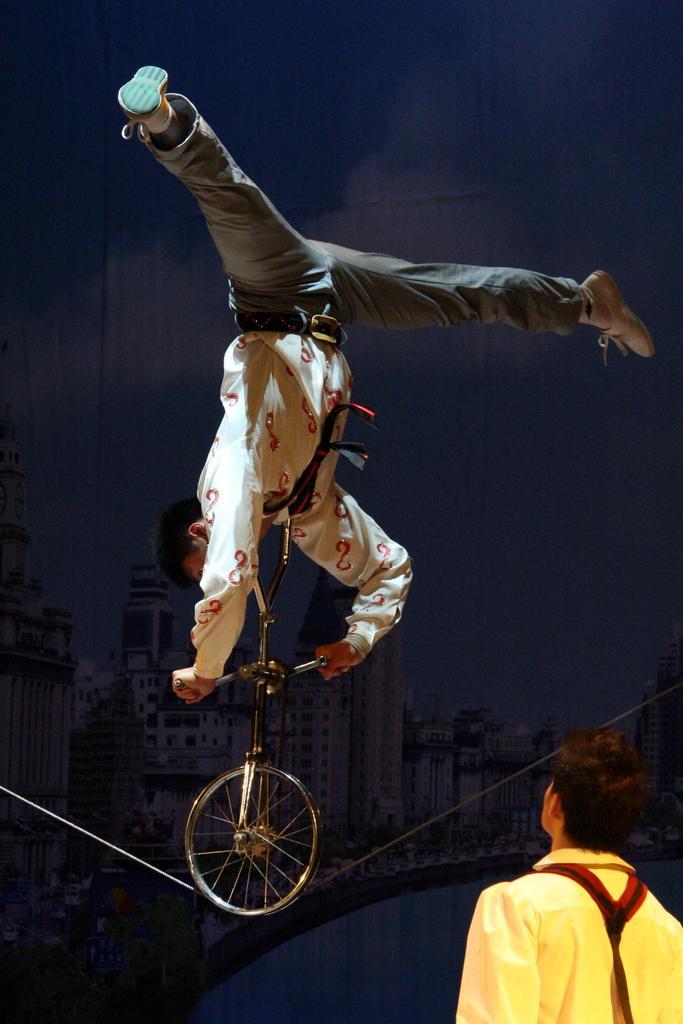Describe this image in one or two sentences. As we can see in the image there is a bicycle and two people. In the background there is a building. The image is little dark. 